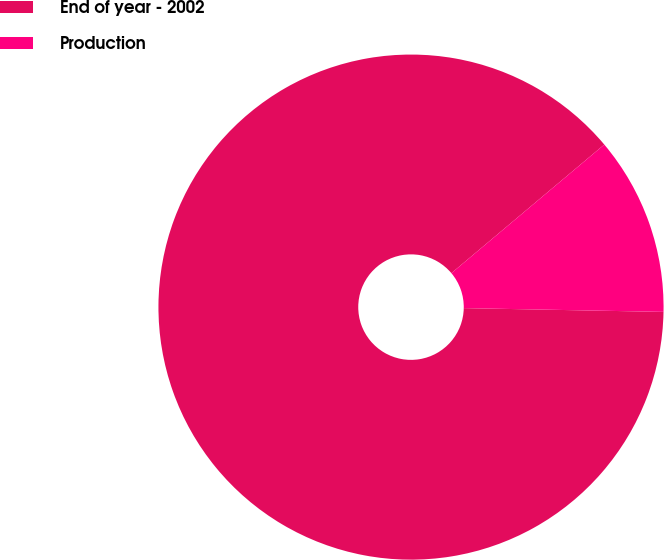Convert chart. <chart><loc_0><loc_0><loc_500><loc_500><pie_chart><fcel>End of year - 2002<fcel>Production<nl><fcel>88.57%<fcel>11.43%<nl></chart> 